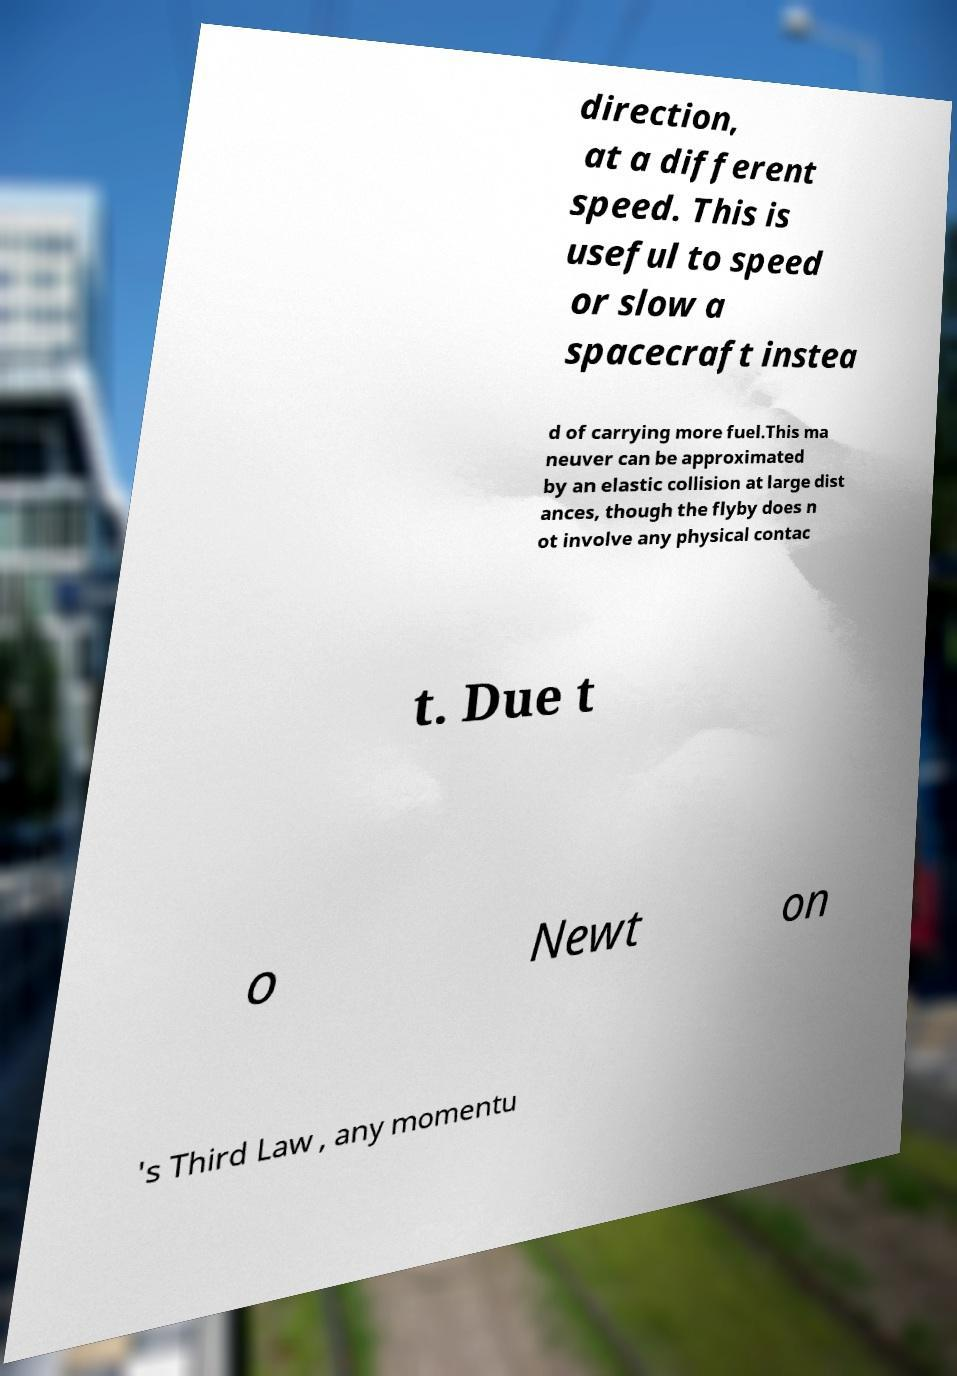Could you extract and type out the text from this image? direction, at a different speed. This is useful to speed or slow a spacecraft instea d of carrying more fuel.This ma neuver can be approximated by an elastic collision at large dist ances, though the flyby does n ot involve any physical contac t. Due t o Newt on 's Third Law , any momentu 